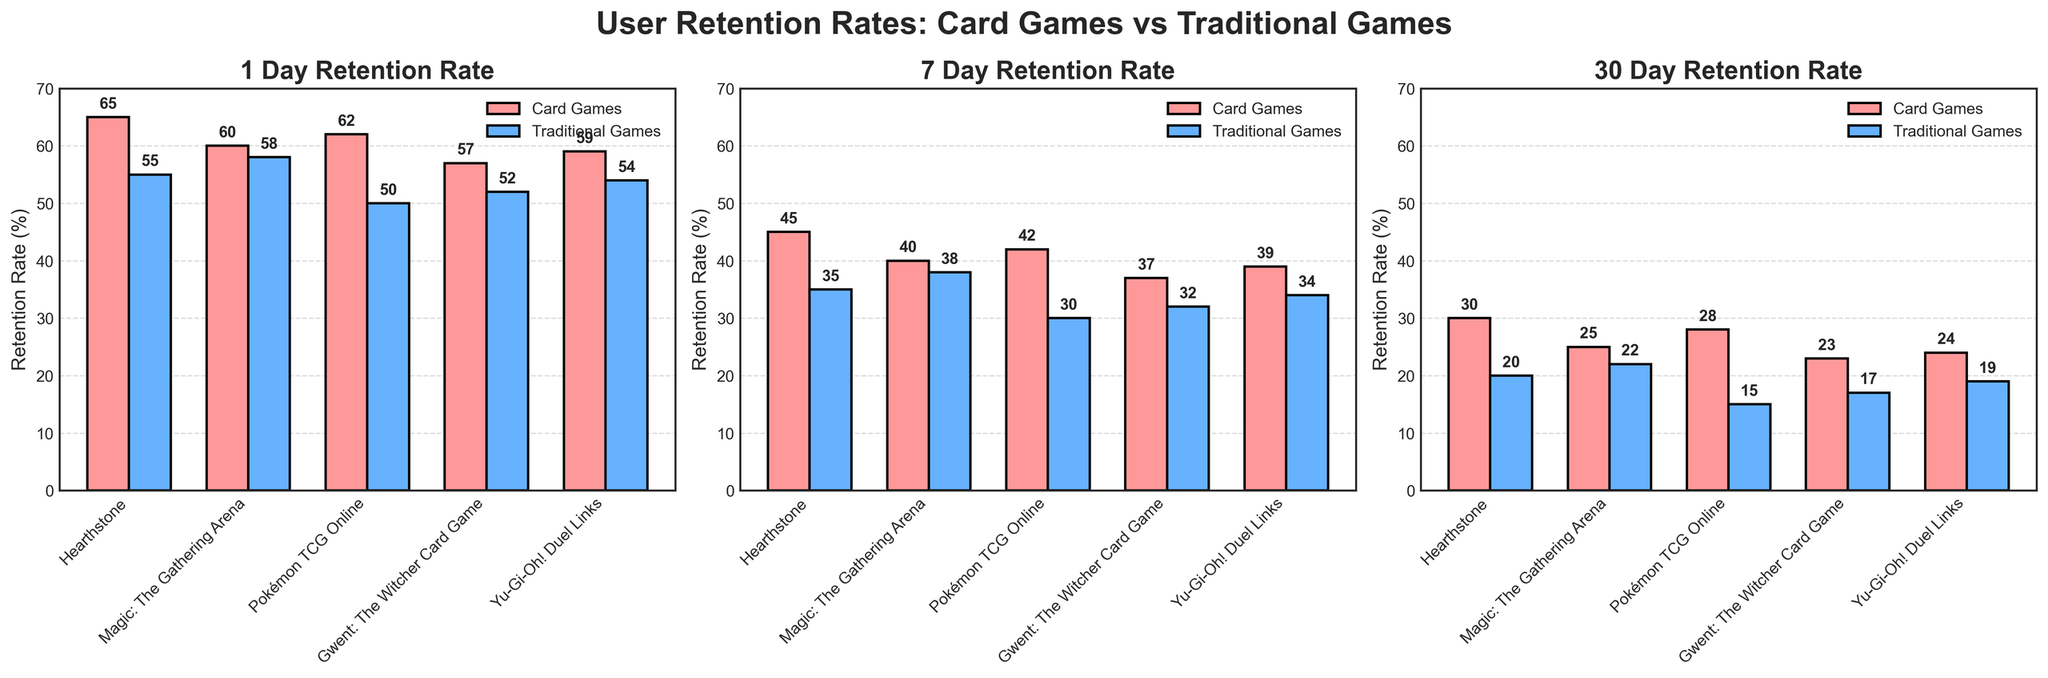What are the titles of the subplots? The titles of the subplots correspond to the retention periods being illustrated. Each subplot title indicates the retention rate at a specific time interval, such as '1 Day Retention Rate', '7 Day Retention Rate', and '30 Day Retention Rate'.
Answer: '1 Day Retention Rate', '7 Day Retention Rate', '30 Day Retention Rate' Which game has the highest 1 Day Retention rate among card games? To determine which card game has the highest 1 Day Retention rate, look at the bar heights for card games under the '1 Day Retention Rate' subplot. The tallest bar represents the highest retention rate.
Answer: Hearthstone What is the difference in 1 Day Retention rate between 'Hearthstone' and 'Candy Crush Saga'? In the '1 Day Retention Rate' subplot, find the bar heights for Hearthstone and Candy Crush Saga. Subtract the retention rate of Candy Crush Saga from that of Hearthstone to find the difference. Hearthstone has a height of 65% and Candy Crush Saga has a height of 55%. The difference is 65% - 55%.
Answer: 10% How does the 7 Day Retention rate of 'Magic: The Gathering Arena' compare with that of 'Angry Birds 2'? Look at the '7 Day Retention Rate' subplot and compare the heights of the bars for Magic: The Gathering Arena and Angry Birds 2. Magic: The Gathering Arena has a height of 40%, and Angry Birds 2 has a height of 30%. Therefore, Magic: The Gathering Arena has a higher retention rate by 10%.
Answer: Magic: The Gathering Arena has a higher retention rate Which game has the lowest 30 Day Retention rate among traditional games? Find the bar in the '30 Day Retention Rate' subplot with the lowest height among traditional games. The game with the shortest bar represents the lowest retention rate. In this case, Angry Birds 2 has a height of 15%, which is the lowest among traditional games.
Answer: Angry Birds 2 What is the average 7 Day Retention rate for all card games? To find the average 7 Day Retention rate for card games, sum up the retention rates for all card games and divide by the number of card games. The retention rates are 45% (Hearthstone), 40% (Magic: The Gathering Arena), 42% (Pokémon TCG Online), 37% (Gwent: The Witcher Card Game), and 39% (Yu-Gi-Oh! Duel Links). Add these values: 45 + 40 + 42 + 37 + 39 = 203. Then, divide by 5 to get the average: 203/5 = 40.6%.
Answer: 40.6% What trend can be observed across different retention periods for 'Clash Royale'? In all three subplots, observe the height of the bars for Clash Royale across the different time intervals. The 1 Day Retention rate is 58%, the 7 Day Retention rate is 38%, and the 30 Day Retention rate is 22%. It shows a decreasing trend as retention period increases.
Answer: Decreasing trend 